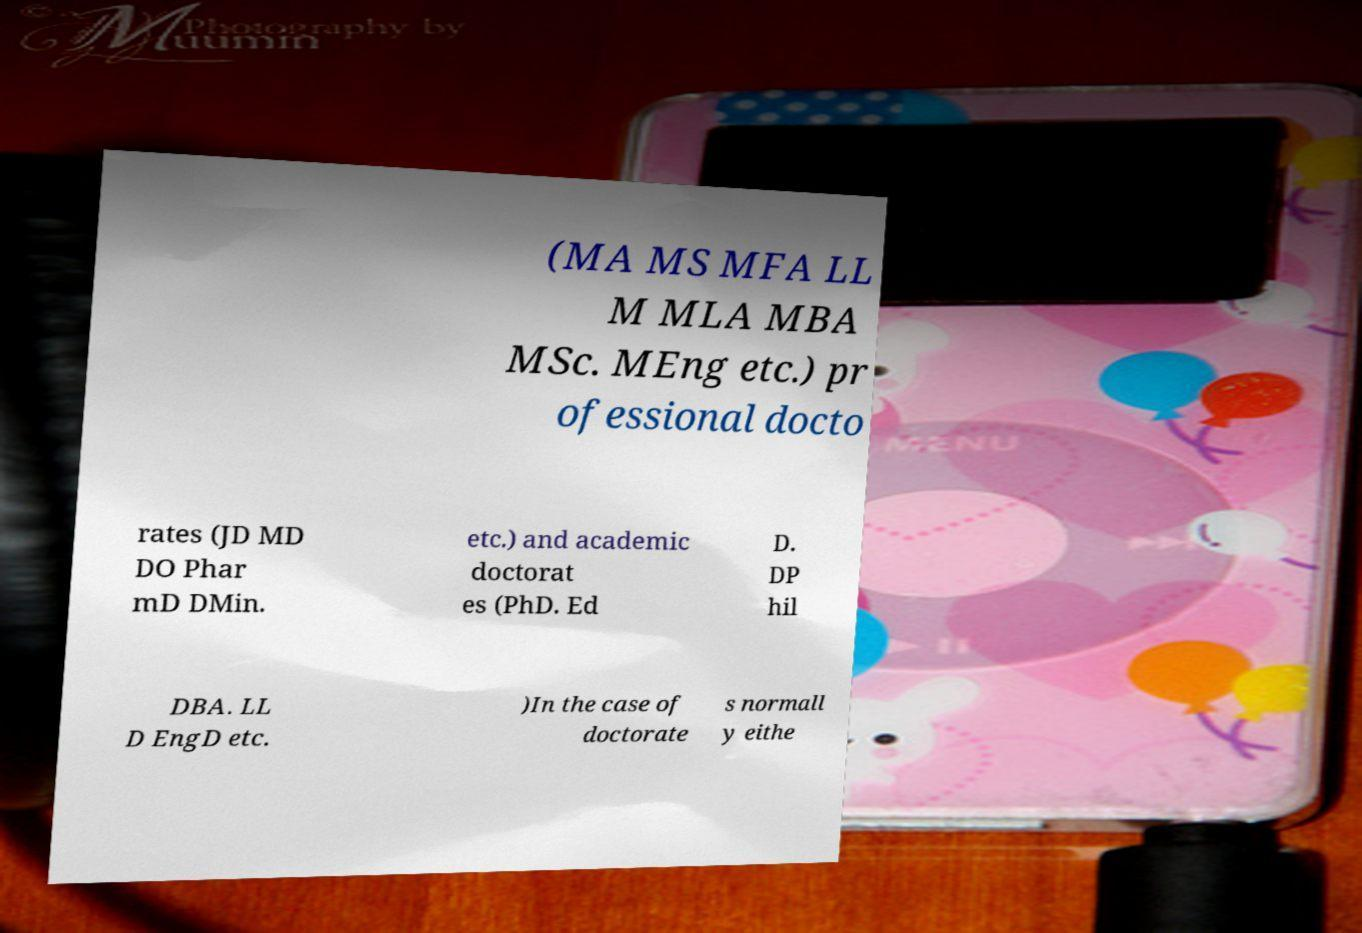Could you extract and type out the text from this image? (MA MS MFA LL M MLA MBA MSc. MEng etc.) pr ofessional docto rates (JD MD DO Phar mD DMin. etc.) and academic doctorat es (PhD. Ed D. DP hil DBA. LL D EngD etc. )In the case of doctorate s normall y eithe 